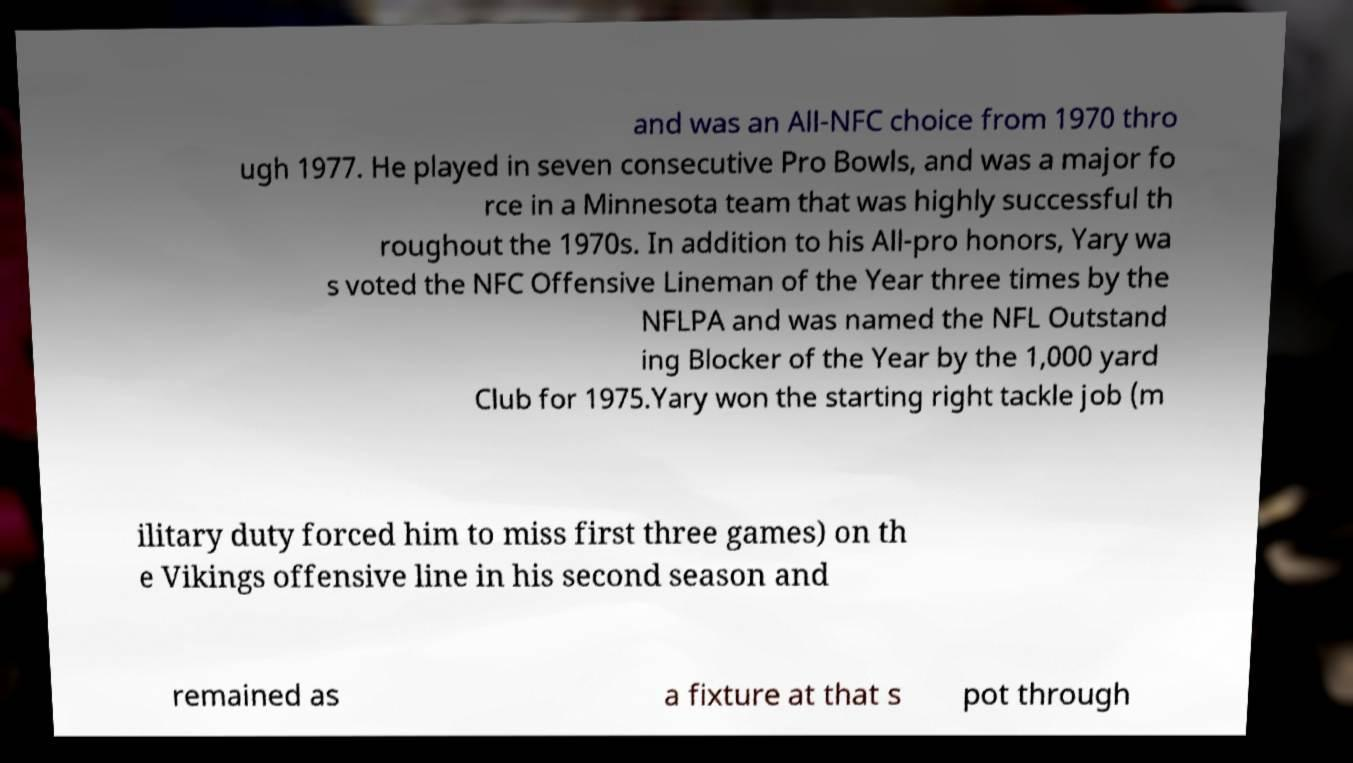Please identify and transcribe the text found in this image. and was an All-NFC choice from 1970 thro ugh 1977. He played in seven consecutive Pro Bowls, and was a major fo rce in a Minnesota team that was highly successful th roughout the 1970s. In addition to his All-pro honors, Yary wa s voted the NFC Offensive Lineman of the Year three times by the NFLPA and was named the NFL Outstand ing Blocker of the Year by the 1,000 yard Club for 1975.Yary won the starting right tackle job (m ilitary duty forced him to miss first three games) on th e Vikings offensive line in his second season and remained as a fixture at that s pot through 